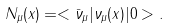<formula> <loc_0><loc_0><loc_500><loc_500>N _ { \mu } ( x ) = < \bar { \nu } _ { \mu } | \nu _ { \mu } ( x ) | 0 > .</formula> 